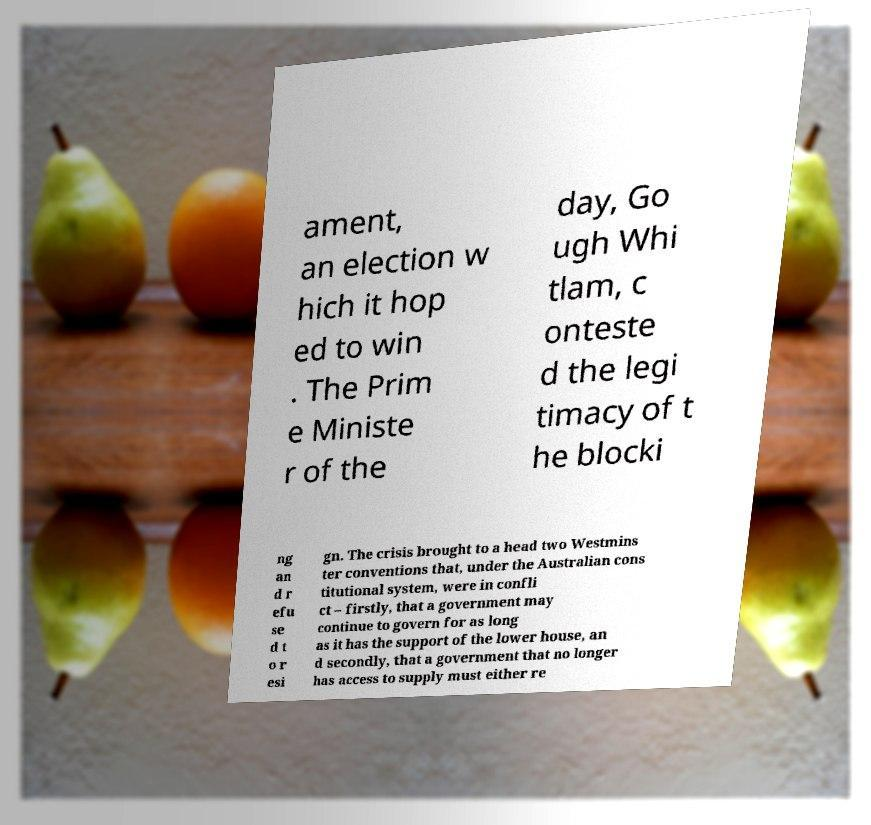Could you assist in decoding the text presented in this image and type it out clearly? ament, an election w hich it hop ed to win . The Prim e Ministe r of the day, Go ugh Whi tlam, c onteste d the legi timacy of t he blocki ng an d r efu se d t o r esi gn. The crisis brought to a head two Westmins ter conventions that, under the Australian cons titutional system, were in confli ct – firstly, that a government may continue to govern for as long as it has the support of the lower house, an d secondly, that a government that no longer has access to supply must either re 